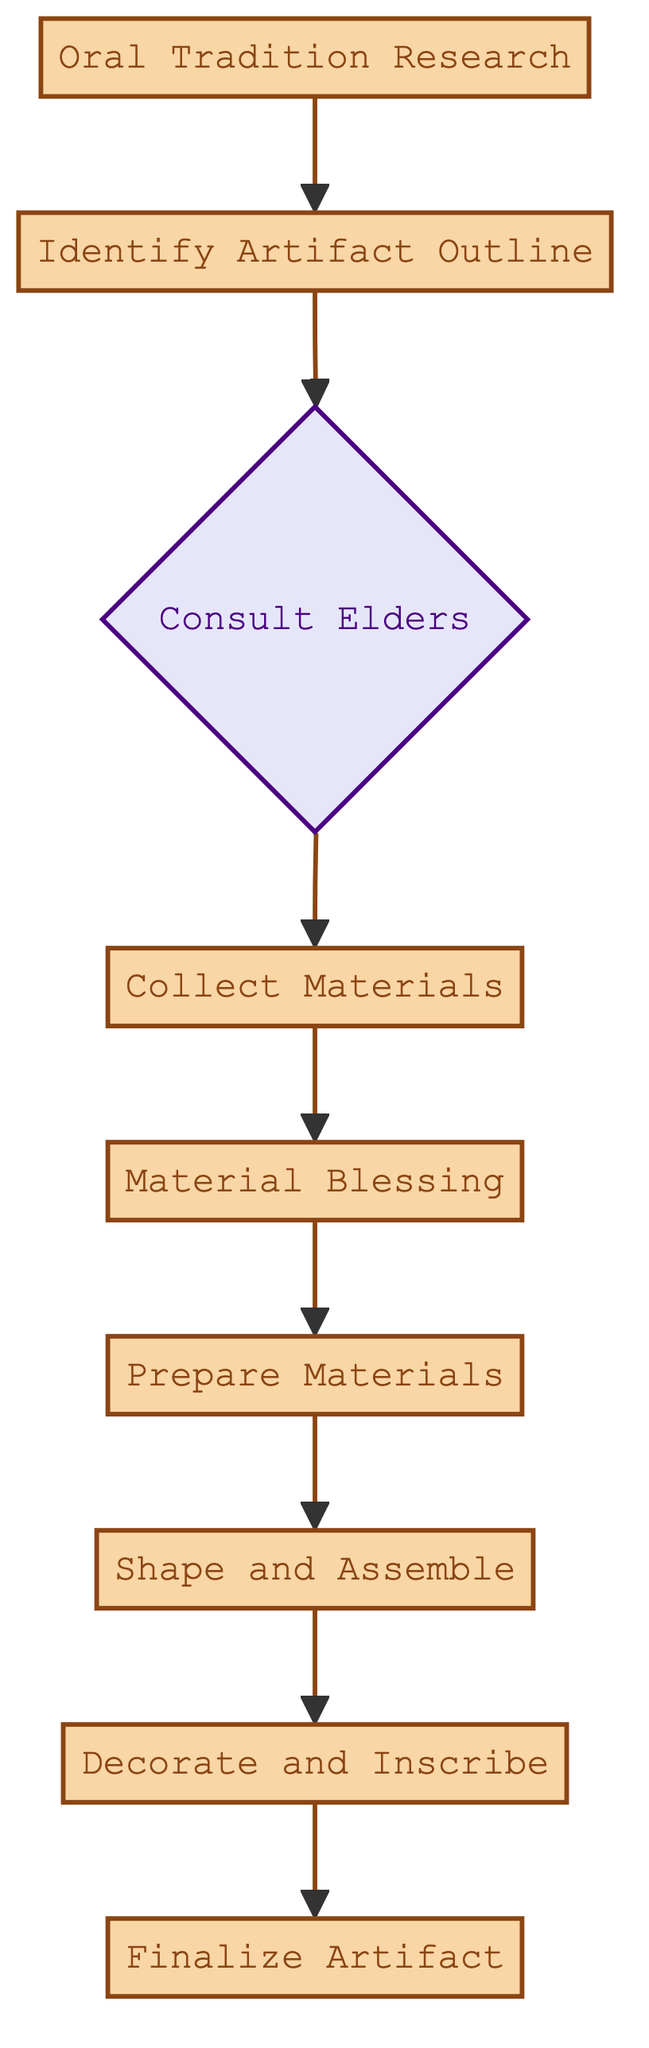What is the first step in the crafting process? The diagram shows that "Oral Tradition Research" is the starting point, as it is the first node in the flowchart.
Answer: Oral Tradition Research What is the final step before completing the artifact? The last node before "Finalize Artifact" is "Decorate and Inscribe," as indicated by the flow from "Shape and Assemble" to "Finalize Artifact."
Answer: Decorate and Inscribe How many processes are involved in the crafting flow? Counting the nodes marked as "Process" in the diagram gives us a total of 8 processes.
Answer: 8 Which step involves gathering materials? The diagram indicates that "Collect Materials" is the step dedicated to gathering raw materials needed for crafting.
Answer: Collect Materials What is the decision point in the crafting process? The node labeled "Consult Elders" is presented as a decision point, where guidance is sought.
Answer: Consult Elders What comes after "Prepare Materials"? The flowchart shows that "Shape and Assemble" follows "Prepare Materials" as the next step in the crafting process.
Answer: Shape and Assemble Which node describes the purpose and design definition of the artifact? The node titled "Identify Artifact Outline" specifies the definition of the artifact's purpose, design, and specifications.
Answer: Identify Artifact Outline How many nodes are connected to the "Consult Elders" decision point? Analyzing the diagram reveals that "Consult Elders" is connected to only one subsequent node, which is "Collect Materials."
Answer: 1 What step follows the ceremonial blessing of materials? According to the flowchart, the step that comes after "Material Blessing" is "Prepare Materials."
Answer: Prepare Materials 